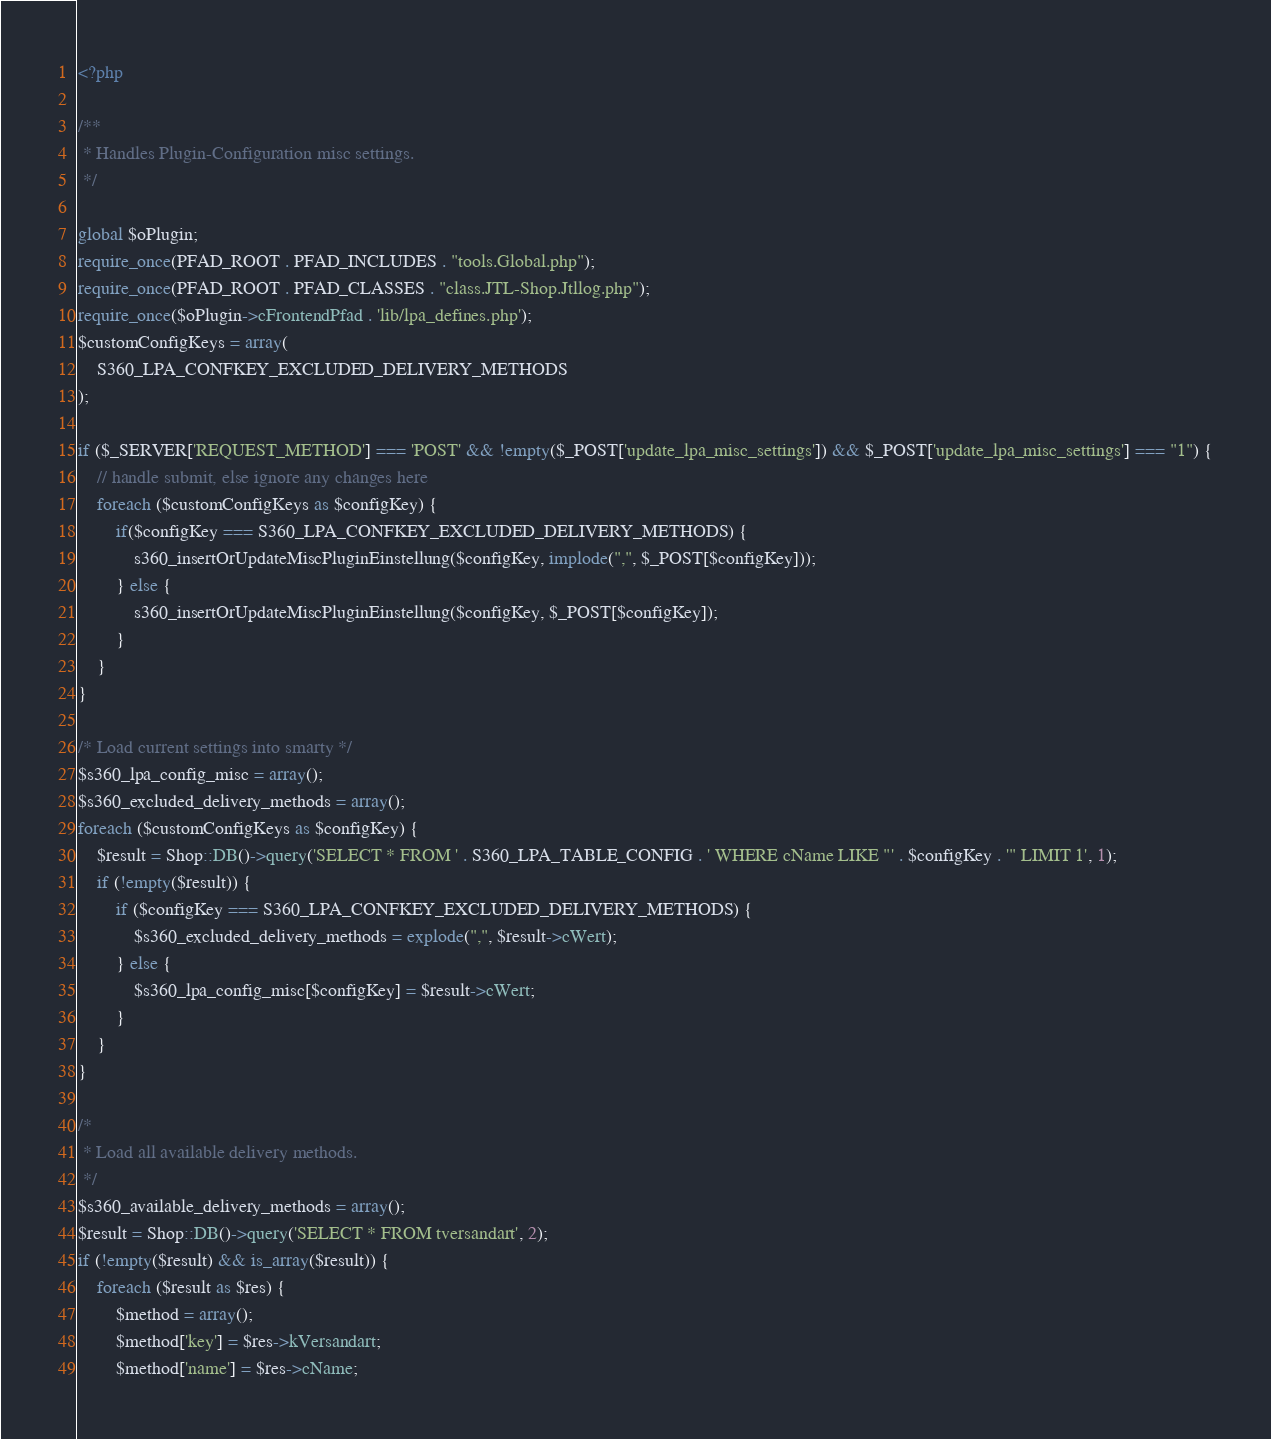<code> <loc_0><loc_0><loc_500><loc_500><_PHP_><?php

/**
 * Handles Plugin-Configuration misc settings.
 */

global $oPlugin;
require_once(PFAD_ROOT . PFAD_INCLUDES . "tools.Global.php");
require_once(PFAD_ROOT . PFAD_CLASSES . "class.JTL-Shop.Jtllog.php");
require_once($oPlugin->cFrontendPfad . 'lib/lpa_defines.php');
$customConfigKeys = array(
    S360_LPA_CONFKEY_EXCLUDED_DELIVERY_METHODS
);

if ($_SERVER['REQUEST_METHOD'] === 'POST' && !empty($_POST['update_lpa_misc_settings']) && $_POST['update_lpa_misc_settings'] === "1") {
    // handle submit, else ignore any changes here
    foreach ($customConfigKeys as $configKey) {
        if($configKey === S360_LPA_CONFKEY_EXCLUDED_DELIVERY_METHODS) {
            s360_insertOrUpdateMiscPluginEinstellung($configKey, implode(",", $_POST[$configKey]));
        } else {
            s360_insertOrUpdateMiscPluginEinstellung($configKey, $_POST[$configKey]);
        }
    }
}

/* Load current settings into smarty */
$s360_lpa_config_misc = array();
$s360_excluded_delivery_methods = array();
foreach ($customConfigKeys as $configKey) {
    $result = Shop::DB()->query('SELECT * FROM ' . S360_LPA_TABLE_CONFIG . ' WHERE cName LIKE "' . $configKey . '" LIMIT 1', 1);
    if (!empty($result)) {
        if ($configKey === S360_LPA_CONFKEY_EXCLUDED_DELIVERY_METHODS) {
            $s360_excluded_delivery_methods = explode(",", $result->cWert);
        } else {
            $s360_lpa_config_misc[$configKey] = $result->cWert;
        }
    }
}

/*
 * Load all available delivery methods.
 */
$s360_available_delivery_methods = array();
$result = Shop::DB()->query('SELECT * FROM tversandart', 2);
if (!empty($result) && is_array($result)) {
    foreach ($result as $res) {
        $method = array();
        $method['key'] = $res->kVersandart;
        $method['name'] = $res->cName;</code> 